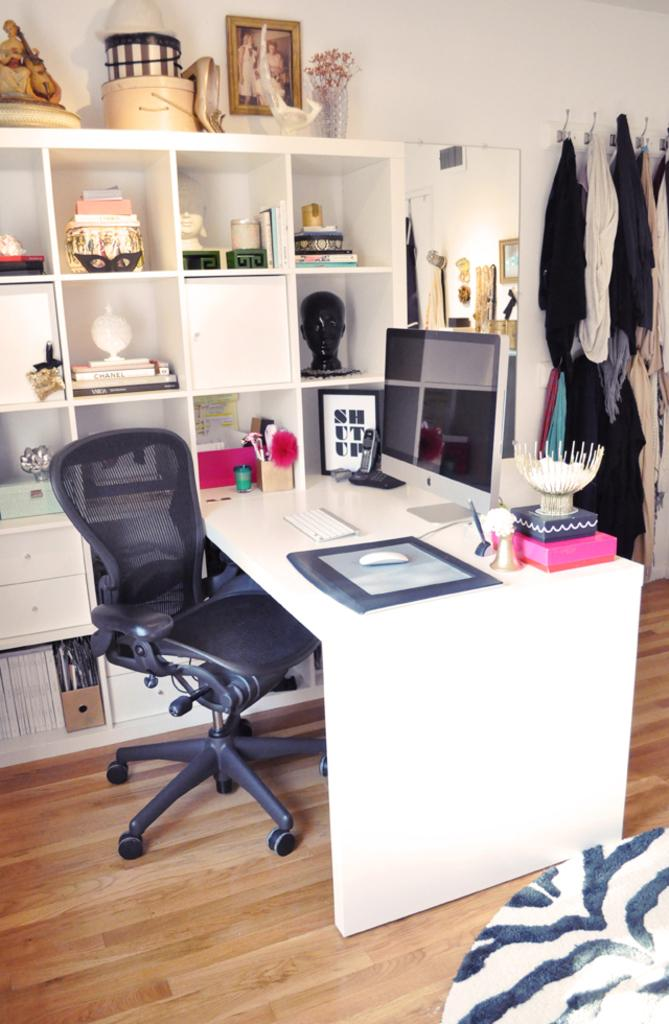<image>
Provide a brief description of the given image. a desk with the word shutup framed on it 